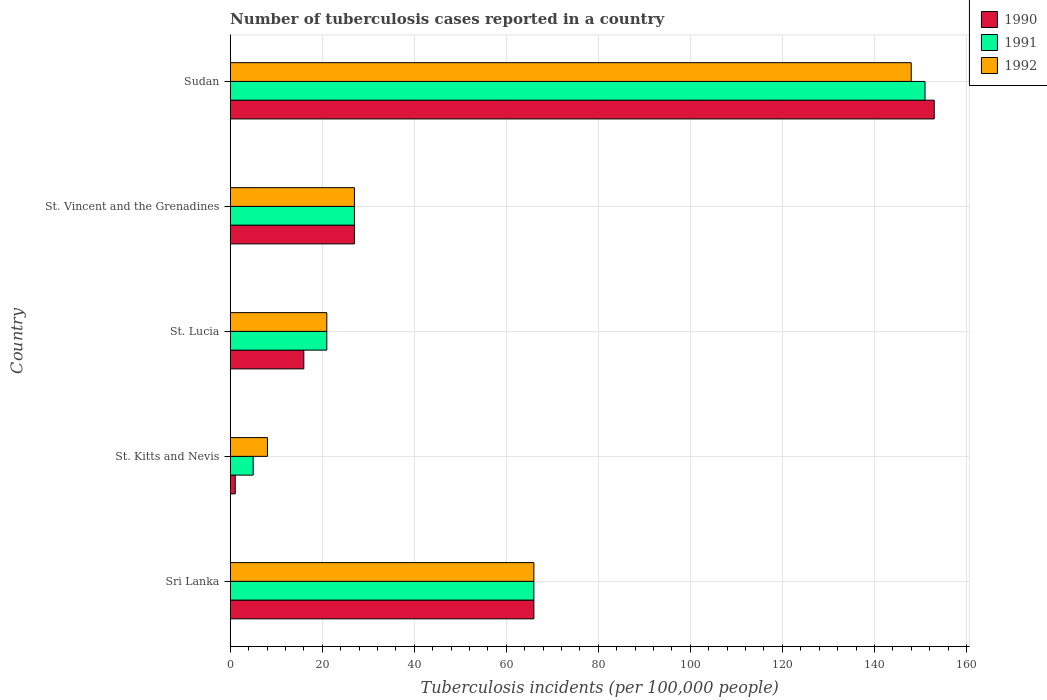How many different coloured bars are there?
Offer a very short reply. 3. Are the number of bars on each tick of the Y-axis equal?
Make the answer very short. Yes. How many bars are there on the 1st tick from the bottom?
Provide a short and direct response. 3. What is the label of the 2nd group of bars from the top?
Give a very brief answer. St. Vincent and the Grenadines. What is the number of tuberculosis cases reported in in 1992 in Sri Lanka?
Your answer should be very brief. 66. Across all countries, what is the maximum number of tuberculosis cases reported in in 1990?
Offer a terse response. 153. Across all countries, what is the minimum number of tuberculosis cases reported in in 1990?
Keep it short and to the point. 1.1. In which country was the number of tuberculosis cases reported in in 1990 maximum?
Your answer should be very brief. Sudan. In which country was the number of tuberculosis cases reported in in 1991 minimum?
Ensure brevity in your answer.  St. Kitts and Nevis. What is the total number of tuberculosis cases reported in in 1990 in the graph?
Keep it short and to the point. 263.1. What is the difference between the number of tuberculosis cases reported in in 1992 in Sri Lanka and that in St. Kitts and Nevis?
Provide a short and direct response. 57.9. What is the difference between the number of tuberculosis cases reported in in 1991 in St. Vincent and the Grenadines and the number of tuberculosis cases reported in in 1990 in St. Lucia?
Offer a very short reply. 11. What is the average number of tuberculosis cases reported in in 1991 per country?
Make the answer very short. 54. In how many countries, is the number of tuberculosis cases reported in in 1990 greater than 152 ?
Your answer should be compact. 1. What is the ratio of the number of tuberculosis cases reported in in 1992 in Sri Lanka to that in St. Kitts and Nevis?
Ensure brevity in your answer.  8.15. Is the difference between the number of tuberculosis cases reported in in 1991 in St. Kitts and Nevis and St. Vincent and the Grenadines greater than the difference between the number of tuberculosis cases reported in in 1990 in St. Kitts and Nevis and St. Vincent and the Grenadines?
Keep it short and to the point. Yes. What is the difference between the highest and the lowest number of tuberculosis cases reported in in 1992?
Your answer should be very brief. 139.9. Is the sum of the number of tuberculosis cases reported in in 1990 in Sri Lanka and St. Lucia greater than the maximum number of tuberculosis cases reported in in 1992 across all countries?
Make the answer very short. No. What does the 2nd bar from the top in St. Vincent and the Grenadines represents?
Give a very brief answer. 1991. What does the 1st bar from the bottom in St. Kitts and Nevis represents?
Provide a short and direct response. 1990. How many bars are there?
Your answer should be compact. 15. What is the difference between two consecutive major ticks on the X-axis?
Provide a succinct answer. 20. Does the graph contain grids?
Offer a very short reply. Yes. How many legend labels are there?
Keep it short and to the point. 3. How are the legend labels stacked?
Provide a succinct answer. Vertical. What is the title of the graph?
Provide a short and direct response. Number of tuberculosis cases reported in a country. Does "1983" appear as one of the legend labels in the graph?
Provide a short and direct response. No. What is the label or title of the X-axis?
Your answer should be compact. Tuberculosis incidents (per 100,0 people). What is the label or title of the Y-axis?
Your response must be concise. Country. What is the Tuberculosis incidents (per 100,000 people) in 1990 in St. Kitts and Nevis?
Give a very brief answer. 1.1. What is the Tuberculosis incidents (per 100,000 people) of 1991 in St. Kitts and Nevis?
Give a very brief answer. 5. What is the Tuberculosis incidents (per 100,000 people) in 1992 in St. Kitts and Nevis?
Provide a succinct answer. 8.1. What is the Tuberculosis incidents (per 100,000 people) in 1992 in St. Lucia?
Keep it short and to the point. 21. What is the Tuberculosis incidents (per 100,000 people) of 1990 in St. Vincent and the Grenadines?
Offer a very short reply. 27. What is the Tuberculosis incidents (per 100,000 people) in 1990 in Sudan?
Offer a very short reply. 153. What is the Tuberculosis incidents (per 100,000 people) in 1991 in Sudan?
Your answer should be very brief. 151. What is the Tuberculosis incidents (per 100,000 people) of 1992 in Sudan?
Make the answer very short. 148. Across all countries, what is the maximum Tuberculosis incidents (per 100,000 people) of 1990?
Keep it short and to the point. 153. Across all countries, what is the maximum Tuberculosis incidents (per 100,000 people) of 1991?
Make the answer very short. 151. Across all countries, what is the maximum Tuberculosis incidents (per 100,000 people) of 1992?
Your response must be concise. 148. Across all countries, what is the minimum Tuberculosis incidents (per 100,000 people) in 1992?
Ensure brevity in your answer.  8.1. What is the total Tuberculosis incidents (per 100,000 people) of 1990 in the graph?
Make the answer very short. 263.1. What is the total Tuberculosis incidents (per 100,000 people) of 1991 in the graph?
Your answer should be very brief. 270. What is the total Tuberculosis incidents (per 100,000 people) of 1992 in the graph?
Your answer should be compact. 270.1. What is the difference between the Tuberculosis incidents (per 100,000 people) of 1990 in Sri Lanka and that in St. Kitts and Nevis?
Provide a succinct answer. 64.9. What is the difference between the Tuberculosis incidents (per 100,000 people) in 1991 in Sri Lanka and that in St. Kitts and Nevis?
Give a very brief answer. 61. What is the difference between the Tuberculosis incidents (per 100,000 people) in 1992 in Sri Lanka and that in St. Kitts and Nevis?
Your answer should be compact. 57.9. What is the difference between the Tuberculosis incidents (per 100,000 people) in 1991 in Sri Lanka and that in St. Lucia?
Offer a terse response. 45. What is the difference between the Tuberculosis incidents (per 100,000 people) in 1990 in Sri Lanka and that in St. Vincent and the Grenadines?
Keep it short and to the point. 39. What is the difference between the Tuberculosis incidents (per 100,000 people) in 1991 in Sri Lanka and that in St. Vincent and the Grenadines?
Provide a succinct answer. 39. What is the difference between the Tuberculosis incidents (per 100,000 people) of 1992 in Sri Lanka and that in St. Vincent and the Grenadines?
Offer a terse response. 39. What is the difference between the Tuberculosis incidents (per 100,000 people) of 1990 in Sri Lanka and that in Sudan?
Provide a succinct answer. -87. What is the difference between the Tuberculosis incidents (per 100,000 people) of 1991 in Sri Lanka and that in Sudan?
Offer a very short reply. -85. What is the difference between the Tuberculosis incidents (per 100,000 people) of 1992 in Sri Lanka and that in Sudan?
Keep it short and to the point. -82. What is the difference between the Tuberculosis incidents (per 100,000 people) of 1990 in St. Kitts and Nevis and that in St. Lucia?
Give a very brief answer. -14.9. What is the difference between the Tuberculosis incidents (per 100,000 people) in 1990 in St. Kitts and Nevis and that in St. Vincent and the Grenadines?
Your answer should be very brief. -25.9. What is the difference between the Tuberculosis incidents (per 100,000 people) of 1991 in St. Kitts and Nevis and that in St. Vincent and the Grenadines?
Offer a very short reply. -22. What is the difference between the Tuberculosis incidents (per 100,000 people) in 1992 in St. Kitts and Nevis and that in St. Vincent and the Grenadines?
Give a very brief answer. -18.9. What is the difference between the Tuberculosis incidents (per 100,000 people) of 1990 in St. Kitts and Nevis and that in Sudan?
Give a very brief answer. -151.9. What is the difference between the Tuberculosis incidents (per 100,000 people) in 1991 in St. Kitts and Nevis and that in Sudan?
Offer a terse response. -146. What is the difference between the Tuberculosis incidents (per 100,000 people) in 1992 in St. Kitts and Nevis and that in Sudan?
Make the answer very short. -139.9. What is the difference between the Tuberculosis incidents (per 100,000 people) in 1990 in St. Lucia and that in St. Vincent and the Grenadines?
Keep it short and to the point. -11. What is the difference between the Tuberculosis incidents (per 100,000 people) in 1992 in St. Lucia and that in St. Vincent and the Grenadines?
Ensure brevity in your answer.  -6. What is the difference between the Tuberculosis incidents (per 100,000 people) in 1990 in St. Lucia and that in Sudan?
Offer a very short reply. -137. What is the difference between the Tuberculosis incidents (per 100,000 people) of 1991 in St. Lucia and that in Sudan?
Your answer should be compact. -130. What is the difference between the Tuberculosis incidents (per 100,000 people) in 1992 in St. Lucia and that in Sudan?
Your response must be concise. -127. What is the difference between the Tuberculosis incidents (per 100,000 people) of 1990 in St. Vincent and the Grenadines and that in Sudan?
Give a very brief answer. -126. What is the difference between the Tuberculosis incidents (per 100,000 people) of 1991 in St. Vincent and the Grenadines and that in Sudan?
Give a very brief answer. -124. What is the difference between the Tuberculosis incidents (per 100,000 people) in 1992 in St. Vincent and the Grenadines and that in Sudan?
Offer a very short reply. -121. What is the difference between the Tuberculosis incidents (per 100,000 people) in 1990 in Sri Lanka and the Tuberculosis incidents (per 100,000 people) in 1992 in St. Kitts and Nevis?
Offer a very short reply. 57.9. What is the difference between the Tuberculosis incidents (per 100,000 people) of 1991 in Sri Lanka and the Tuberculosis incidents (per 100,000 people) of 1992 in St. Kitts and Nevis?
Your response must be concise. 57.9. What is the difference between the Tuberculosis incidents (per 100,000 people) in 1991 in Sri Lanka and the Tuberculosis incidents (per 100,000 people) in 1992 in St. Lucia?
Ensure brevity in your answer.  45. What is the difference between the Tuberculosis incidents (per 100,000 people) in 1990 in Sri Lanka and the Tuberculosis incidents (per 100,000 people) in 1991 in St. Vincent and the Grenadines?
Provide a succinct answer. 39. What is the difference between the Tuberculosis incidents (per 100,000 people) in 1990 in Sri Lanka and the Tuberculosis incidents (per 100,000 people) in 1991 in Sudan?
Your answer should be very brief. -85. What is the difference between the Tuberculosis incidents (per 100,000 people) of 1990 in Sri Lanka and the Tuberculosis incidents (per 100,000 people) of 1992 in Sudan?
Your answer should be very brief. -82. What is the difference between the Tuberculosis incidents (per 100,000 people) of 1991 in Sri Lanka and the Tuberculosis incidents (per 100,000 people) of 1992 in Sudan?
Provide a short and direct response. -82. What is the difference between the Tuberculosis incidents (per 100,000 people) in 1990 in St. Kitts and Nevis and the Tuberculosis incidents (per 100,000 people) in 1991 in St. Lucia?
Ensure brevity in your answer.  -19.9. What is the difference between the Tuberculosis incidents (per 100,000 people) of 1990 in St. Kitts and Nevis and the Tuberculosis incidents (per 100,000 people) of 1992 in St. Lucia?
Keep it short and to the point. -19.9. What is the difference between the Tuberculosis incidents (per 100,000 people) in 1991 in St. Kitts and Nevis and the Tuberculosis incidents (per 100,000 people) in 1992 in St. Lucia?
Offer a terse response. -16. What is the difference between the Tuberculosis incidents (per 100,000 people) of 1990 in St. Kitts and Nevis and the Tuberculosis incidents (per 100,000 people) of 1991 in St. Vincent and the Grenadines?
Your response must be concise. -25.9. What is the difference between the Tuberculosis incidents (per 100,000 people) in 1990 in St. Kitts and Nevis and the Tuberculosis incidents (per 100,000 people) in 1992 in St. Vincent and the Grenadines?
Ensure brevity in your answer.  -25.9. What is the difference between the Tuberculosis incidents (per 100,000 people) in 1991 in St. Kitts and Nevis and the Tuberculosis incidents (per 100,000 people) in 1992 in St. Vincent and the Grenadines?
Offer a very short reply. -22. What is the difference between the Tuberculosis incidents (per 100,000 people) of 1990 in St. Kitts and Nevis and the Tuberculosis incidents (per 100,000 people) of 1991 in Sudan?
Provide a succinct answer. -149.9. What is the difference between the Tuberculosis incidents (per 100,000 people) of 1990 in St. Kitts and Nevis and the Tuberculosis incidents (per 100,000 people) of 1992 in Sudan?
Your response must be concise. -146.9. What is the difference between the Tuberculosis incidents (per 100,000 people) in 1991 in St. Kitts and Nevis and the Tuberculosis incidents (per 100,000 people) in 1992 in Sudan?
Make the answer very short. -143. What is the difference between the Tuberculosis incidents (per 100,000 people) in 1990 in St. Lucia and the Tuberculosis incidents (per 100,000 people) in 1991 in St. Vincent and the Grenadines?
Keep it short and to the point. -11. What is the difference between the Tuberculosis incidents (per 100,000 people) of 1991 in St. Lucia and the Tuberculosis incidents (per 100,000 people) of 1992 in St. Vincent and the Grenadines?
Give a very brief answer. -6. What is the difference between the Tuberculosis incidents (per 100,000 people) of 1990 in St. Lucia and the Tuberculosis incidents (per 100,000 people) of 1991 in Sudan?
Your answer should be very brief. -135. What is the difference between the Tuberculosis incidents (per 100,000 people) in 1990 in St. Lucia and the Tuberculosis incidents (per 100,000 people) in 1992 in Sudan?
Offer a terse response. -132. What is the difference between the Tuberculosis incidents (per 100,000 people) of 1991 in St. Lucia and the Tuberculosis incidents (per 100,000 people) of 1992 in Sudan?
Give a very brief answer. -127. What is the difference between the Tuberculosis incidents (per 100,000 people) in 1990 in St. Vincent and the Grenadines and the Tuberculosis incidents (per 100,000 people) in 1991 in Sudan?
Give a very brief answer. -124. What is the difference between the Tuberculosis incidents (per 100,000 people) of 1990 in St. Vincent and the Grenadines and the Tuberculosis incidents (per 100,000 people) of 1992 in Sudan?
Provide a short and direct response. -121. What is the difference between the Tuberculosis incidents (per 100,000 people) of 1991 in St. Vincent and the Grenadines and the Tuberculosis incidents (per 100,000 people) of 1992 in Sudan?
Your response must be concise. -121. What is the average Tuberculosis incidents (per 100,000 people) in 1990 per country?
Make the answer very short. 52.62. What is the average Tuberculosis incidents (per 100,000 people) of 1991 per country?
Offer a terse response. 54. What is the average Tuberculosis incidents (per 100,000 people) of 1992 per country?
Give a very brief answer. 54.02. What is the difference between the Tuberculosis incidents (per 100,000 people) in 1990 and Tuberculosis incidents (per 100,000 people) in 1991 in Sri Lanka?
Your answer should be compact. 0. What is the difference between the Tuberculosis incidents (per 100,000 people) in 1991 and Tuberculosis incidents (per 100,000 people) in 1992 in St. Lucia?
Your response must be concise. 0. What is the difference between the Tuberculosis incidents (per 100,000 people) in 1990 and Tuberculosis incidents (per 100,000 people) in 1991 in St. Vincent and the Grenadines?
Your answer should be compact. 0. What is the difference between the Tuberculosis incidents (per 100,000 people) in 1990 and Tuberculosis incidents (per 100,000 people) in 1992 in St. Vincent and the Grenadines?
Offer a terse response. 0. What is the difference between the Tuberculosis incidents (per 100,000 people) in 1990 and Tuberculosis incidents (per 100,000 people) in 1991 in Sudan?
Offer a very short reply. 2. What is the ratio of the Tuberculosis incidents (per 100,000 people) in 1990 in Sri Lanka to that in St. Kitts and Nevis?
Keep it short and to the point. 60. What is the ratio of the Tuberculosis incidents (per 100,000 people) of 1991 in Sri Lanka to that in St. Kitts and Nevis?
Provide a succinct answer. 13.2. What is the ratio of the Tuberculosis incidents (per 100,000 people) in 1992 in Sri Lanka to that in St. Kitts and Nevis?
Your answer should be compact. 8.15. What is the ratio of the Tuberculosis incidents (per 100,000 people) of 1990 in Sri Lanka to that in St. Lucia?
Give a very brief answer. 4.12. What is the ratio of the Tuberculosis incidents (per 100,000 people) in 1991 in Sri Lanka to that in St. Lucia?
Provide a succinct answer. 3.14. What is the ratio of the Tuberculosis incidents (per 100,000 people) of 1992 in Sri Lanka to that in St. Lucia?
Your response must be concise. 3.14. What is the ratio of the Tuberculosis incidents (per 100,000 people) in 1990 in Sri Lanka to that in St. Vincent and the Grenadines?
Your response must be concise. 2.44. What is the ratio of the Tuberculosis incidents (per 100,000 people) in 1991 in Sri Lanka to that in St. Vincent and the Grenadines?
Give a very brief answer. 2.44. What is the ratio of the Tuberculosis incidents (per 100,000 people) in 1992 in Sri Lanka to that in St. Vincent and the Grenadines?
Provide a succinct answer. 2.44. What is the ratio of the Tuberculosis incidents (per 100,000 people) in 1990 in Sri Lanka to that in Sudan?
Make the answer very short. 0.43. What is the ratio of the Tuberculosis incidents (per 100,000 people) of 1991 in Sri Lanka to that in Sudan?
Your answer should be very brief. 0.44. What is the ratio of the Tuberculosis incidents (per 100,000 people) in 1992 in Sri Lanka to that in Sudan?
Ensure brevity in your answer.  0.45. What is the ratio of the Tuberculosis incidents (per 100,000 people) in 1990 in St. Kitts and Nevis to that in St. Lucia?
Provide a short and direct response. 0.07. What is the ratio of the Tuberculosis incidents (per 100,000 people) in 1991 in St. Kitts and Nevis to that in St. Lucia?
Your answer should be compact. 0.24. What is the ratio of the Tuberculosis incidents (per 100,000 people) of 1992 in St. Kitts and Nevis to that in St. Lucia?
Provide a short and direct response. 0.39. What is the ratio of the Tuberculosis incidents (per 100,000 people) in 1990 in St. Kitts and Nevis to that in St. Vincent and the Grenadines?
Offer a very short reply. 0.04. What is the ratio of the Tuberculosis incidents (per 100,000 people) in 1991 in St. Kitts and Nevis to that in St. Vincent and the Grenadines?
Provide a succinct answer. 0.19. What is the ratio of the Tuberculosis incidents (per 100,000 people) in 1990 in St. Kitts and Nevis to that in Sudan?
Keep it short and to the point. 0.01. What is the ratio of the Tuberculosis incidents (per 100,000 people) in 1991 in St. Kitts and Nevis to that in Sudan?
Your answer should be very brief. 0.03. What is the ratio of the Tuberculosis incidents (per 100,000 people) of 1992 in St. Kitts and Nevis to that in Sudan?
Offer a very short reply. 0.05. What is the ratio of the Tuberculosis incidents (per 100,000 people) of 1990 in St. Lucia to that in St. Vincent and the Grenadines?
Offer a very short reply. 0.59. What is the ratio of the Tuberculosis incidents (per 100,000 people) of 1991 in St. Lucia to that in St. Vincent and the Grenadines?
Provide a succinct answer. 0.78. What is the ratio of the Tuberculosis incidents (per 100,000 people) in 1992 in St. Lucia to that in St. Vincent and the Grenadines?
Your answer should be compact. 0.78. What is the ratio of the Tuberculosis incidents (per 100,000 people) of 1990 in St. Lucia to that in Sudan?
Offer a terse response. 0.1. What is the ratio of the Tuberculosis incidents (per 100,000 people) of 1991 in St. Lucia to that in Sudan?
Offer a terse response. 0.14. What is the ratio of the Tuberculosis incidents (per 100,000 people) of 1992 in St. Lucia to that in Sudan?
Your answer should be compact. 0.14. What is the ratio of the Tuberculosis incidents (per 100,000 people) in 1990 in St. Vincent and the Grenadines to that in Sudan?
Your response must be concise. 0.18. What is the ratio of the Tuberculosis incidents (per 100,000 people) of 1991 in St. Vincent and the Grenadines to that in Sudan?
Offer a very short reply. 0.18. What is the ratio of the Tuberculosis incidents (per 100,000 people) of 1992 in St. Vincent and the Grenadines to that in Sudan?
Your response must be concise. 0.18. What is the difference between the highest and the second highest Tuberculosis incidents (per 100,000 people) of 1990?
Ensure brevity in your answer.  87. What is the difference between the highest and the second highest Tuberculosis incidents (per 100,000 people) of 1992?
Your response must be concise. 82. What is the difference between the highest and the lowest Tuberculosis incidents (per 100,000 people) in 1990?
Keep it short and to the point. 151.9. What is the difference between the highest and the lowest Tuberculosis incidents (per 100,000 people) in 1991?
Offer a very short reply. 146. What is the difference between the highest and the lowest Tuberculosis incidents (per 100,000 people) of 1992?
Provide a succinct answer. 139.9. 